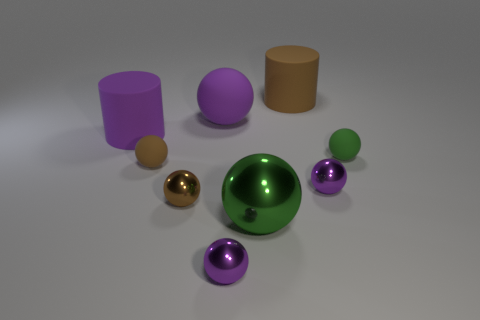Do the brown matte ball and the purple rubber cylinder have the same size?
Provide a succinct answer. No. Is the color of the large matte ball the same as the metallic thing on the right side of the brown cylinder?
Make the answer very short. Yes. There is a tiny brown object that is the same material as the large brown cylinder; what shape is it?
Your response must be concise. Sphere. There is a brown matte object in front of the tiny green thing; does it have the same shape as the small brown metallic object?
Offer a very short reply. Yes. What size is the green sphere to the right of the purple object that is on the right side of the large green object?
Provide a short and direct response. Small. There is another cylinder that is the same material as the large purple cylinder; what is its color?
Offer a very short reply. Brown. What number of other spheres are the same size as the brown metallic sphere?
Make the answer very short. 4. What number of blue things are either metallic things or big cylinders?
Ensure brevity in your answer.  0. What number of things are brown matte objects or green things that are on the left side of the tiny green object?
Provide a succinct answer. 3. There is a big purple thing on the right side of the small brown matte ball; what is its material?
Your answer should be compact. Rubber. 